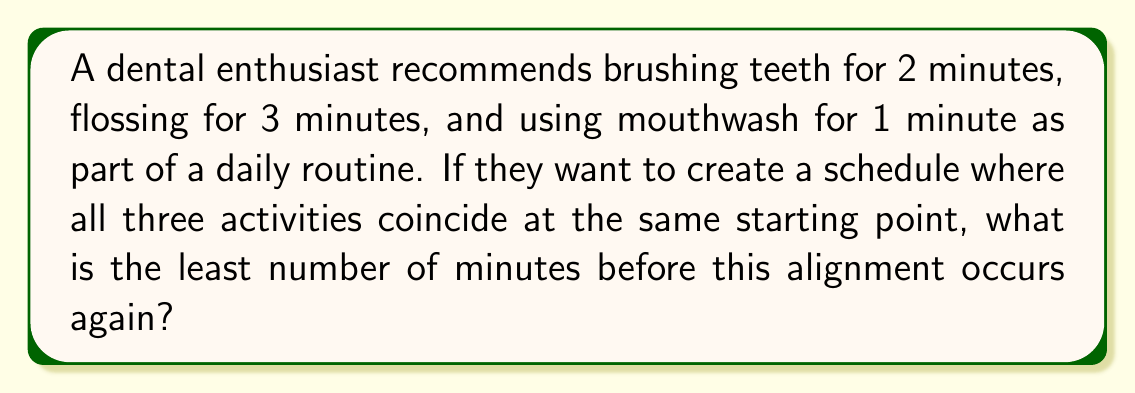Show me your answer to this math problem. To solve this problem, we need to find the Least Common Multiple (LCM) of 2, 3, and 1.

Step 1: List the prime factors of each number:
$2 = 2$
$3 = 3$
$1 = 1$

Step 2: Identify the highest power of each prime factor:
$2^1$
$3^1$
$1^1 = 1$ (we can ignore this as it doesn't affect the LCM)

Step 3: Multiply these highest powers:
$LCM = 2^1 \times 3^1 = 2 \times 3 = 6$

Therefore, the least number of minutes before all three activities align again is 6 minutes.

We can verify this:
- Brushing (2 minutes): 2, 4, 6
- Flossing (3 minutes): 3, 6
- Mouthwash (1 minute): 1, 2, 3, 4, 5, 6

At 6 minutes, all three activities coincide.
Answer: 6 minutes 